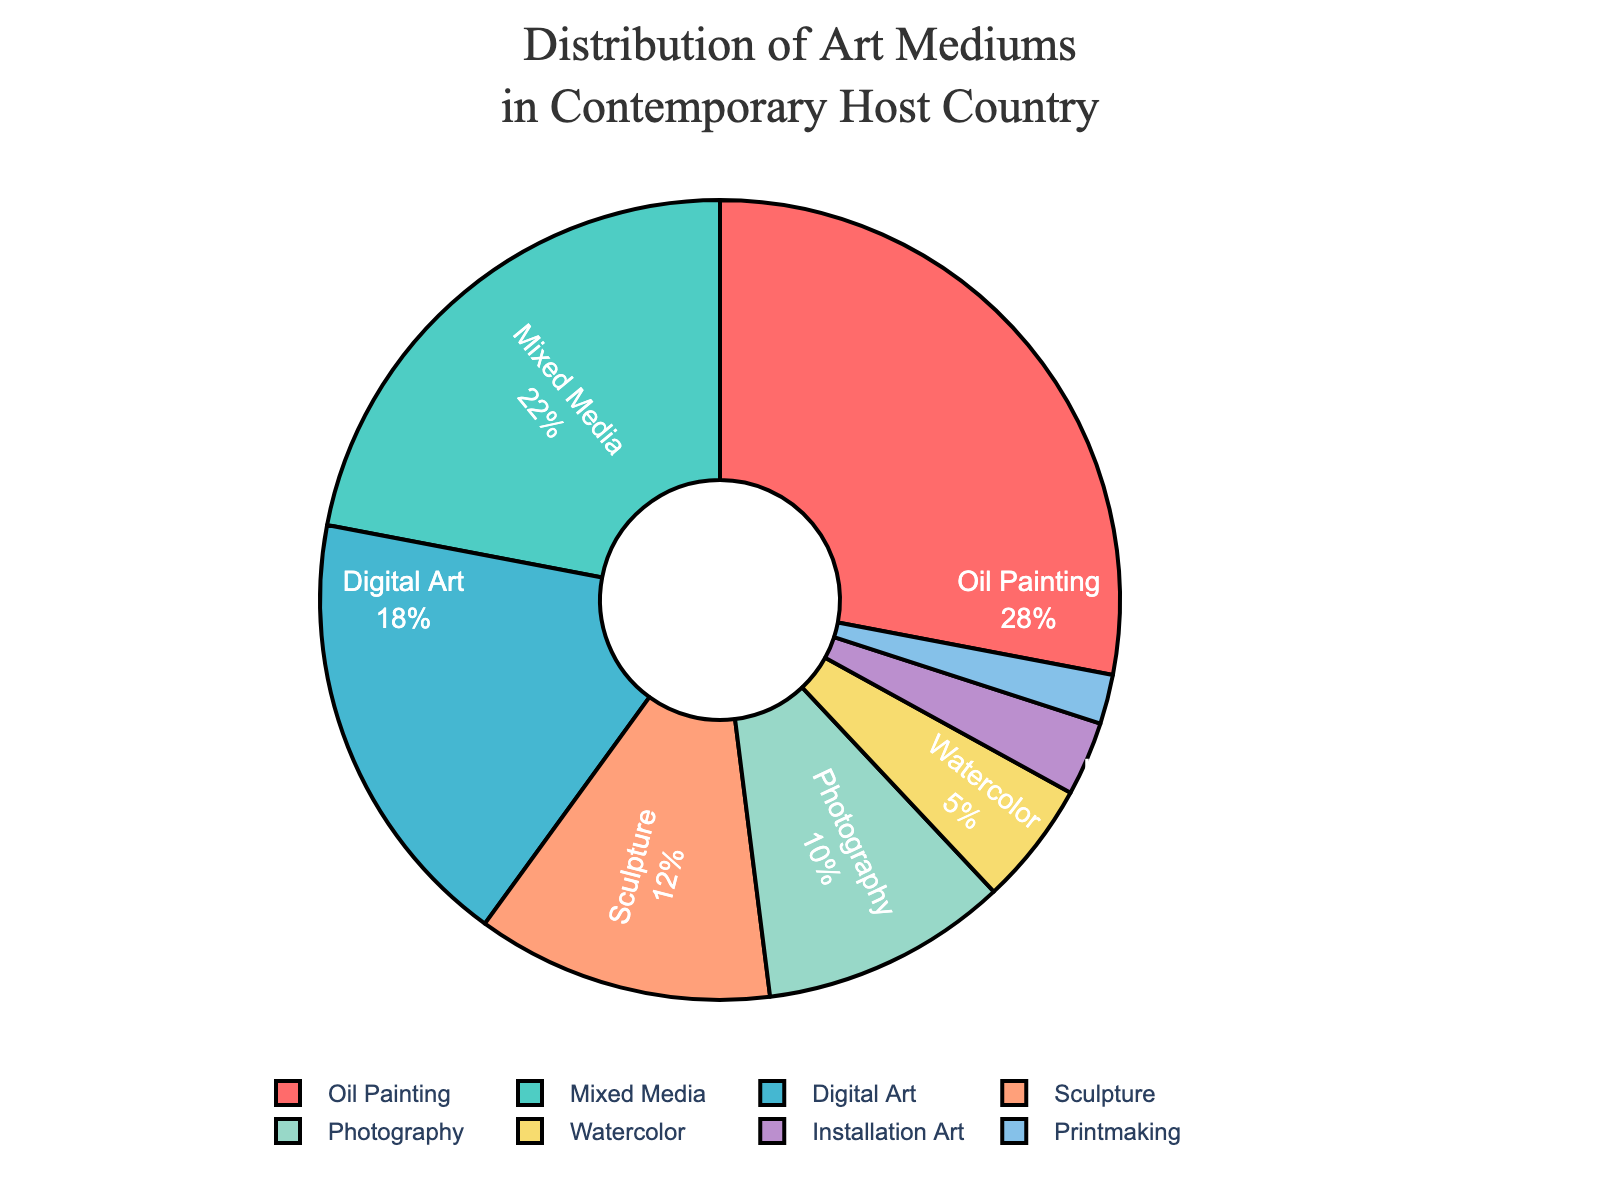What's the largest segment in the pie chart? The segment with the largest percentage represents the most popular art medium used by contemporary artists in the host country. From the list, "Oil Painting" has the highest percentage at 28%.
Answer: Oil Painting Which medium has a smaller percentage, Photography or Digital Art? To compare the percentages, we look at the values for Photography and Digital Art. Photography has 10%, and Digital Art has 18%. Since 10% is less than 18%, Photography has a smaller percentage.
Answer: Photography How much more popular is Mixed Media than Installation Art? To find out how much more popular Mixed Media is, subtract the percentage of Installation Art from the percentage of Mixed Media. Mixed Media is 22%, and Installation Art is 3%. 22% - 3% = 19%.
Answer: 19% What is the combined percentage of Oil Painting and Watercolor? To get the combined percentage, add the percentage of Oil Painting and Watercolor. Oil Painting is 28%, and Watercolor is 5%. 28% + 5% = 33%.
Answer: 33% Which three mediums have the smallest percentages? The mediums with the smallest percentages can be identified by looking at the data. Printmaking has 2%, Installation Art has 3%, and Watercolor has 5%. These are the three smallest percentages.
Answer: Printmaking, Installation Art, Watercolor Are there more artists using Digital Art or Mixed Media? To compare the number of artists using each medium, look at their respective percentages. Digital Art has 18%, and Mixed Media has 22%. Since 22% is greater than 18%, more artists are using Mixed Media.
Answer: Mixed Media What is the difference in percentage between Sculpture and Photography? To find the difference, subtract the smaller percentage (Photography) from the larger percentage (Sculpture). Sculpture is 12%, and Photography is 10%. 12% - 10% = 2%.
Answer: 2% Which segment is represented by a blue color? To determine which segment is represented by the blue color, match the described colors with the segments in the pie chart. Digital Art is represented by a blue color.
Answer: Digital Art Is the percentage of Mixed Media greater than the combined percentage of Printmaking and Installation Art? First, calculate the combined percentage of Printmaking and Installation Art. Printmaking is 2%, and Installation Art is 3%. 2% + 3% = 5%. Then, compare it with the percentage of Mixed Media, which is 22%. Since 22% is greater than 5%, Mixed Media has a greater percentage.
Answer: Yes What is the average percentage of Sculpture, Photography, and Watercolor? To calculate the average, sum up the percentages of Sculpture, Photography, and Watercolor, then divide by 3. Sculpture is 12%, Photography is 10%, and Watercolor is 5%. 12% + 10% + 5% = 27%. 27% / 3 = 9%.
Answer: 9% 